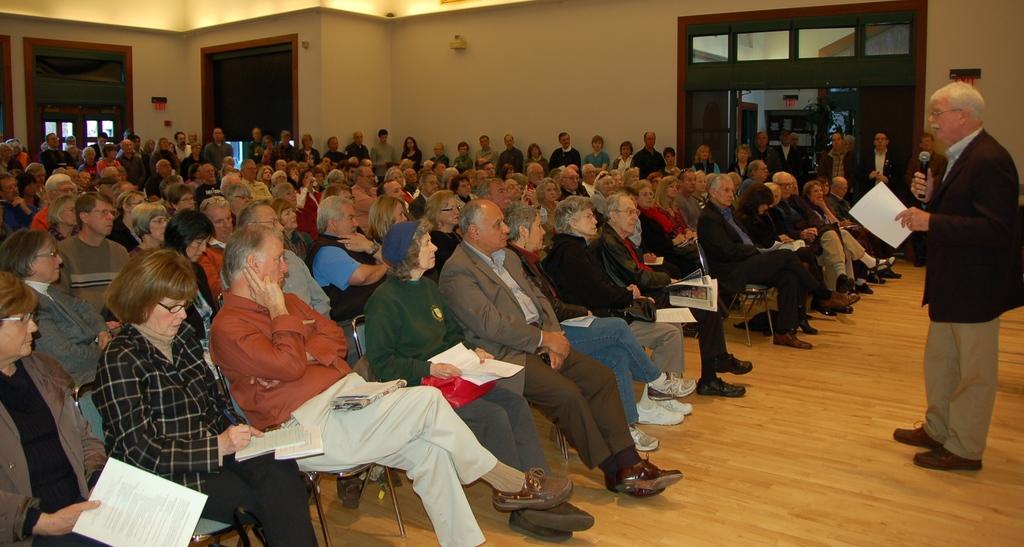How would you summarize this image in a sentence or two? This picture is clicked inside. On the right there is a man holding a paper, microphone and wearing a suit and standing on the ground. On the left we can see the group of people holding some objects and sitting on the chairs. In the background we can see the doors, wall and group of people standing on the ground. 